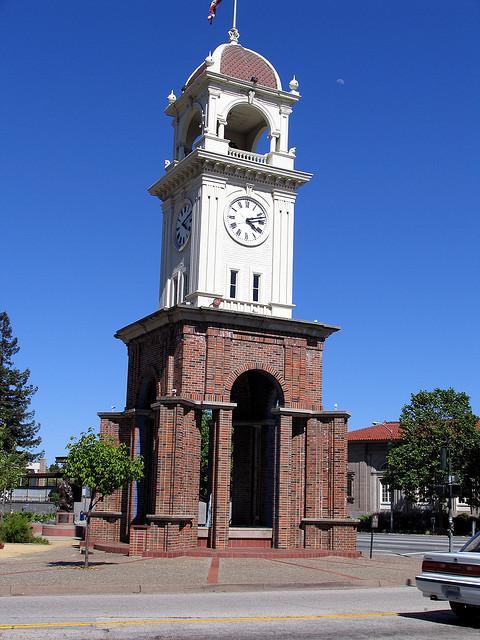What can someone know by looking at the white tower?

Choices:
A) date
B) time
C) year
D) month time 